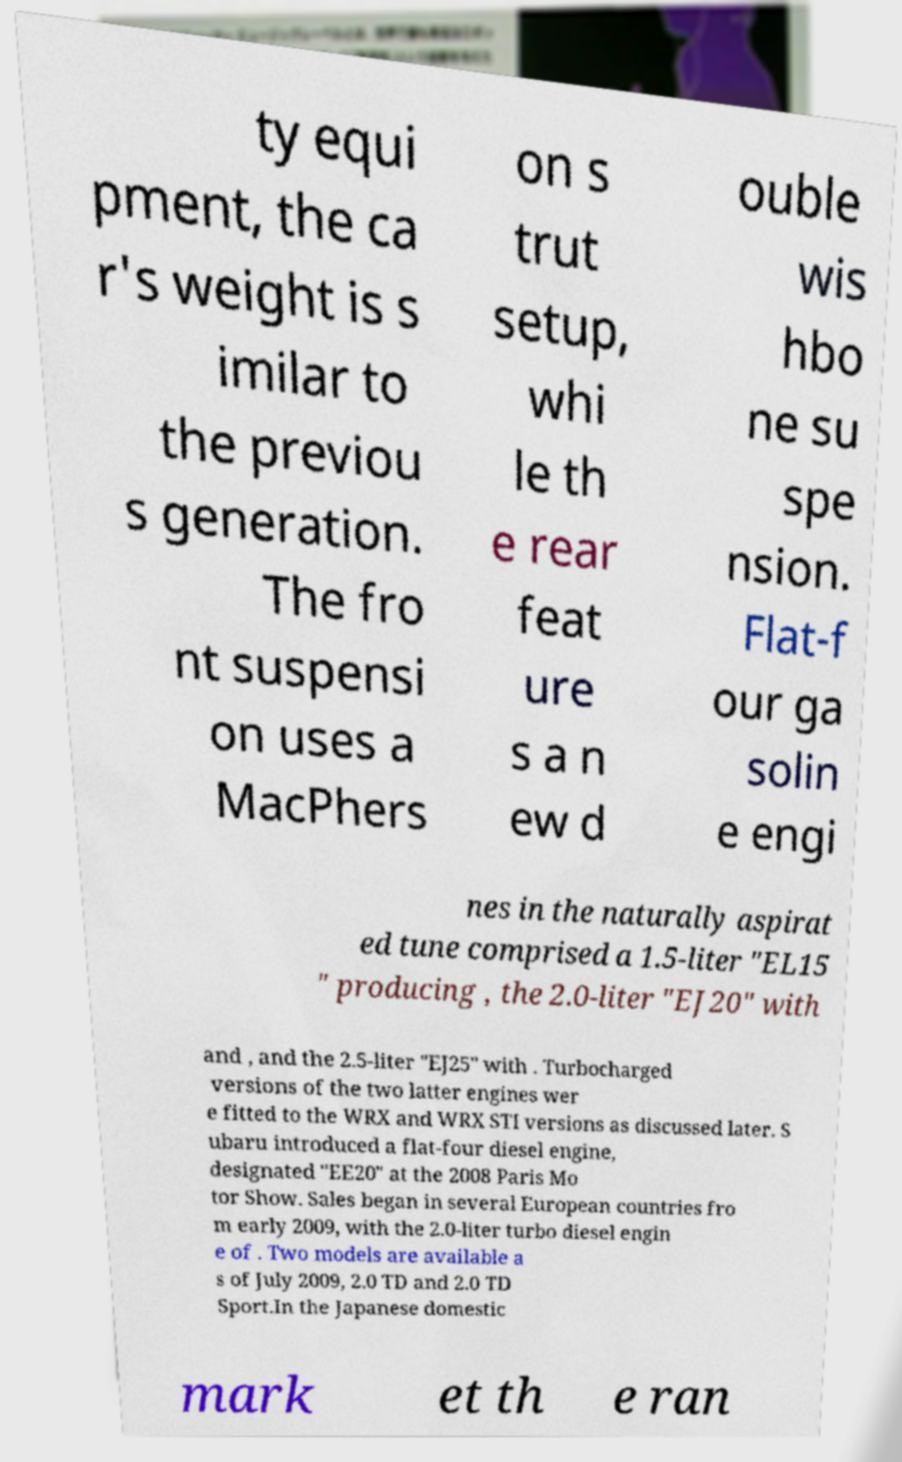Please read and relay the text visible in this image. What does it say? ty equi pment, the ca r's weight is s imilar to the previou s generation. The fro nt suspensi on uses a MacPhers on s trut setup, whi le th e rear feat ure s a n ew d ouble wis hbo ne su spe nsion. Flat-f our ga solin e engi nes in the naturally aspirat ed tune comprised a 1.5-liter "EL15 " producing , the 2.0-liter "EJ20" with and , and the 2.5-liter "EJ25" with . Turbocharged versions of the two latter engines wer e fitted to the WRX and WRX STI versions as discussed later. S ubaru introduced a flat-four diesel engine, designated "EE20" at the 2008 Paris Mo tor Show. Sales began in several European countries fro m early 2009, with the 2.0-liter turbo diesel engin e of . Two models are available a s of July 2009, 2.0 TD and 2.0 TD Sport.In the Japanese domestic mark et th e ran 